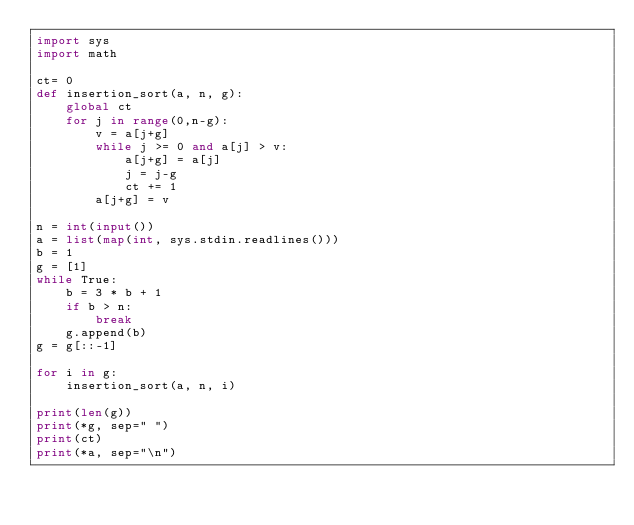Convert code to text. <code><loc_0><loc_0><loc_500><loc_500><_Python_>import sys
import math

ct= 0
def insertion_sort(a, n, g):
    global ct
    for j in range(0,n-g):
        v = a[j+g]
        while j >= 0 and a[j] > v:
            a[j+g] = a[j]
            j = j-g
            ct += 1
        a[j+g] = v

n = int(input())
a = list(map(int, sys.stdin.readlines()))
b = 1
g = [1]
while True:
    b = 3 * b + 1
    if b > n:
        break
    g.append(b)
g = g[::-1]

for i in g:
    insertion_sort(a, n, i)

print(len(g))
print(*g, sep=" ")
print(ct)
print(*a, sep="\n")

</code> 